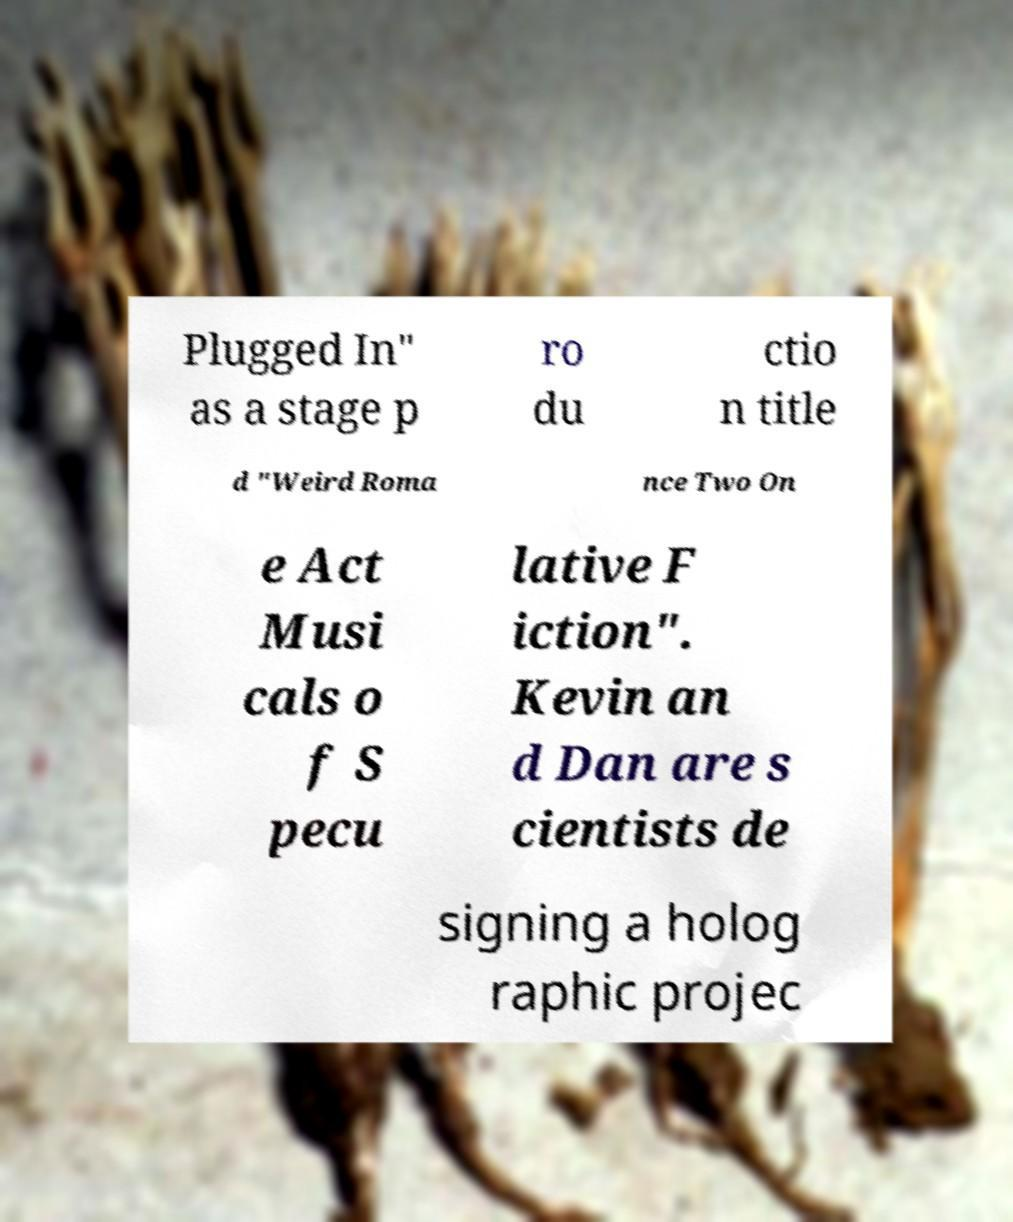For documentation purposes, I need the text within this image transcribed. Could you provide that? Plugged In" as a stage p ro du ctio n title d "Weird Roma nce Two On e Act Musi cals o f S pecu lative F iction". Kevin an d Dan are s cientists de signing a holog raphic projec 